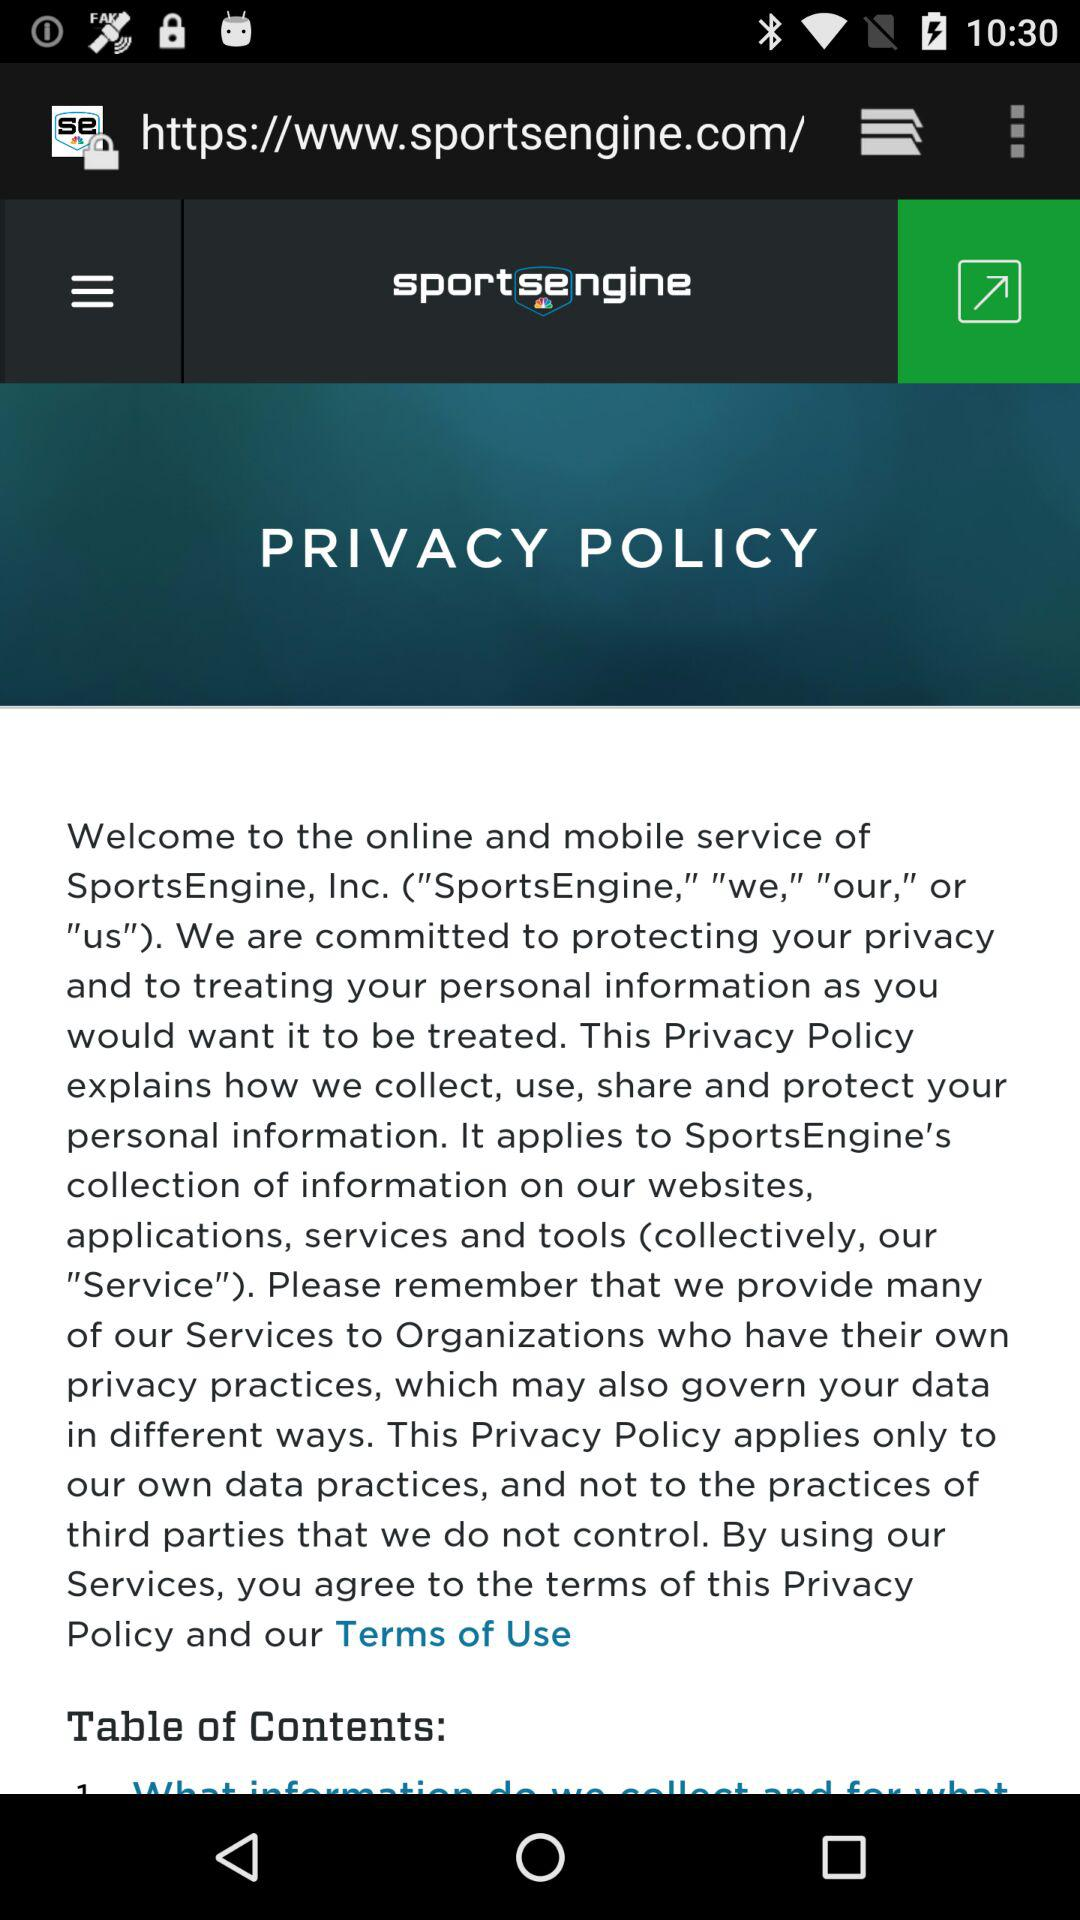What is the web app name? The web app name is "sportsengine". 